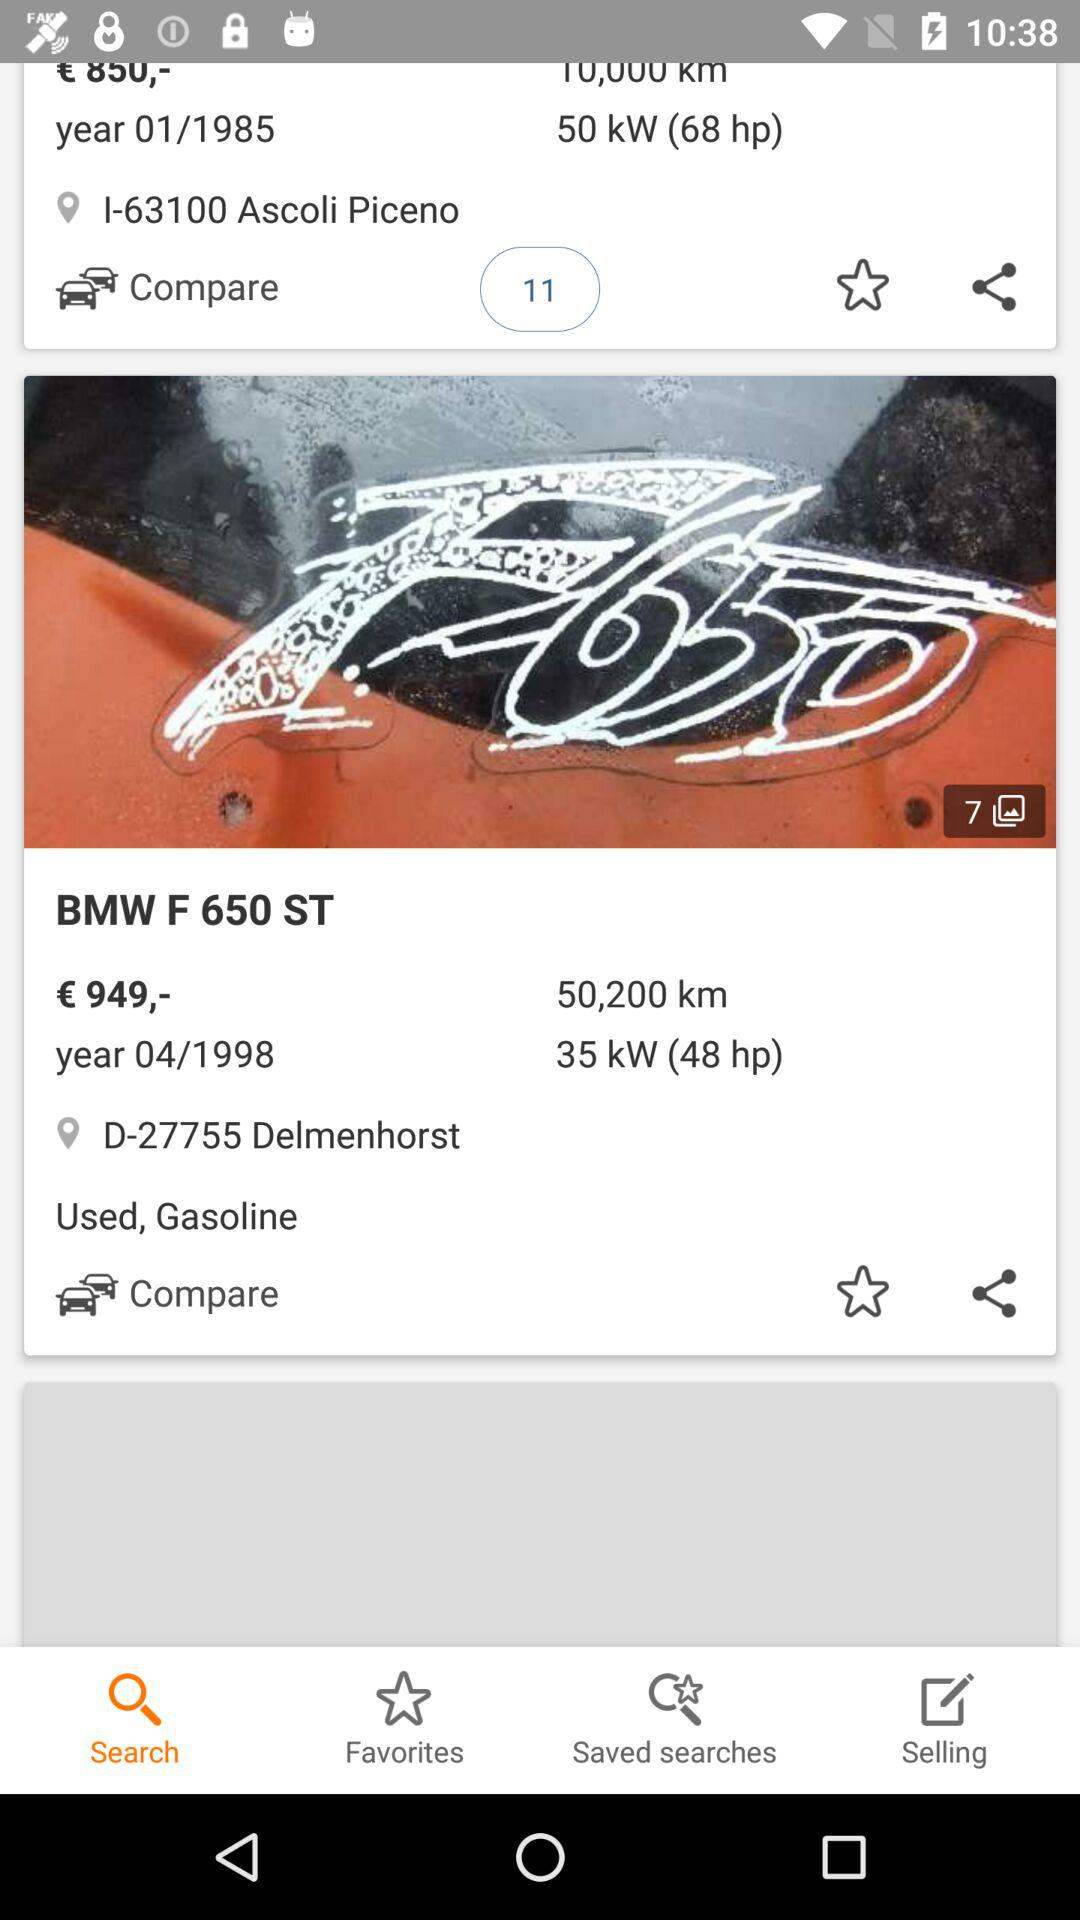What is the distance in kilometers shown for the BMW F 650 ST? The distance shown for the BMW F 650 ST is 50,200 km. 